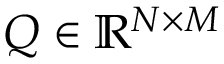Convert formula to latex. <formula><loc_0><loc_0><loc_500><loc_500>Q \in \mathbb { R } ^ { N \times M }</formula> 